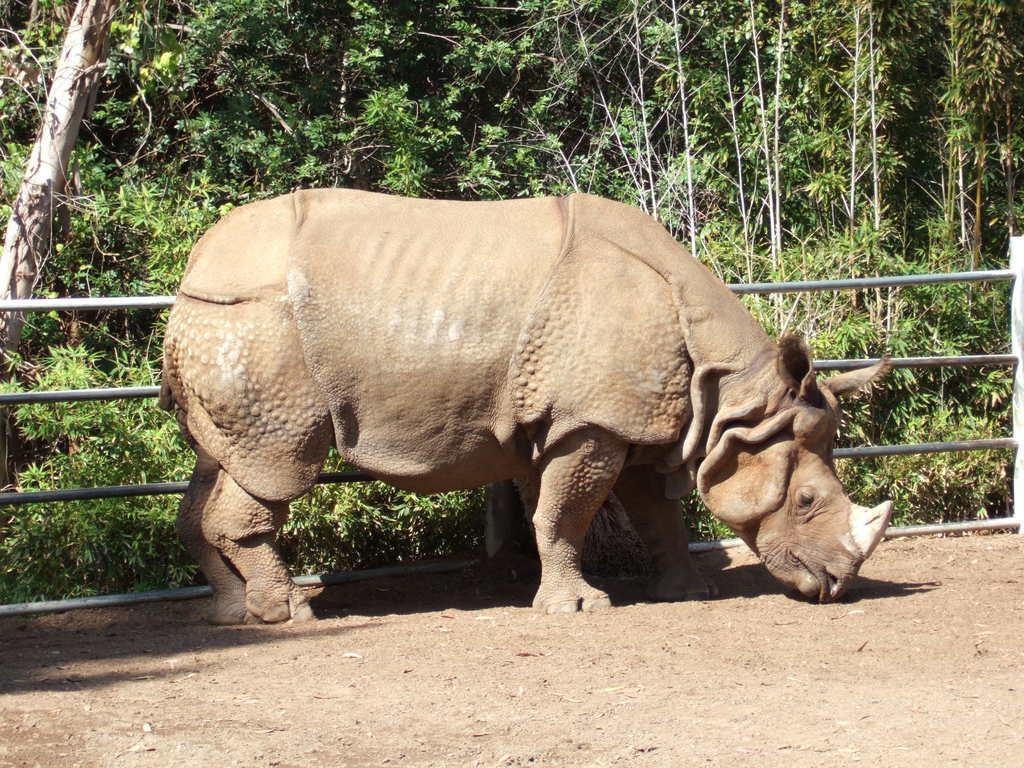In one or two sentences, can you explain what this image depicts? In this picture I can see there is a rhinoceros and in the backdrop I can see there is a fence and there are plants and trees in the backdrop. 